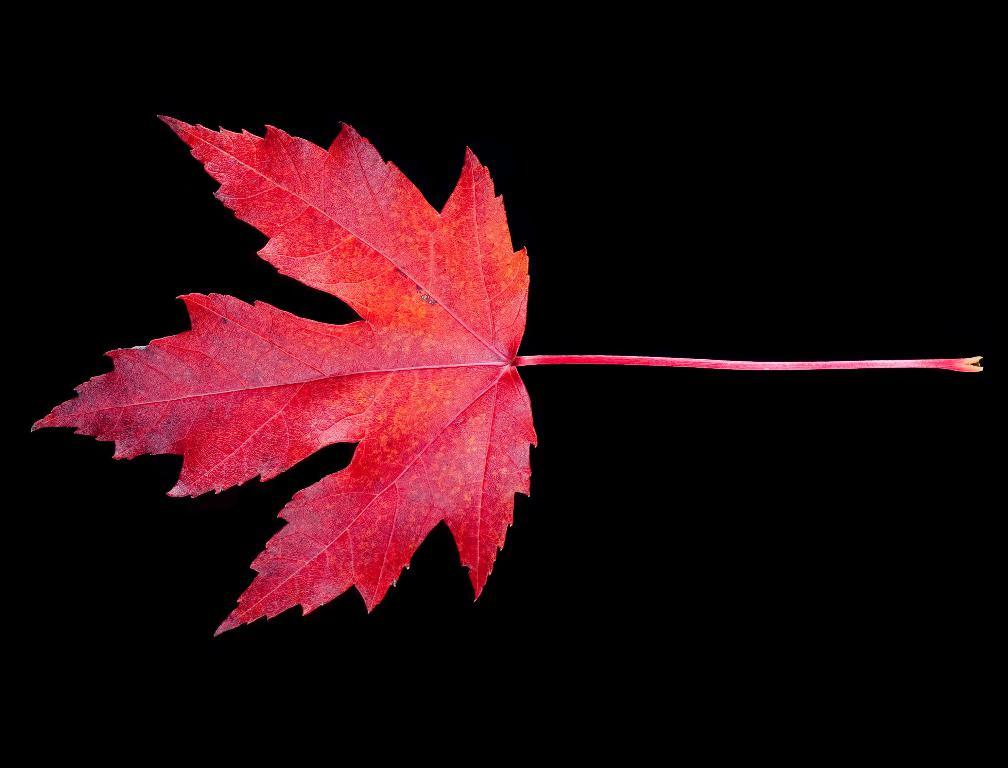What is the main subject of the image? The main subject of the image is a leaf. Can you describe the background of the image? The background of the image is dark. How many beds can be seen in the image? There are no beds present in the image; it features a leaf and a dark background. What type of wood is the leaf made of in the image? The image does not provide information about the type of wood, as it only features a leaf and a dark background. 